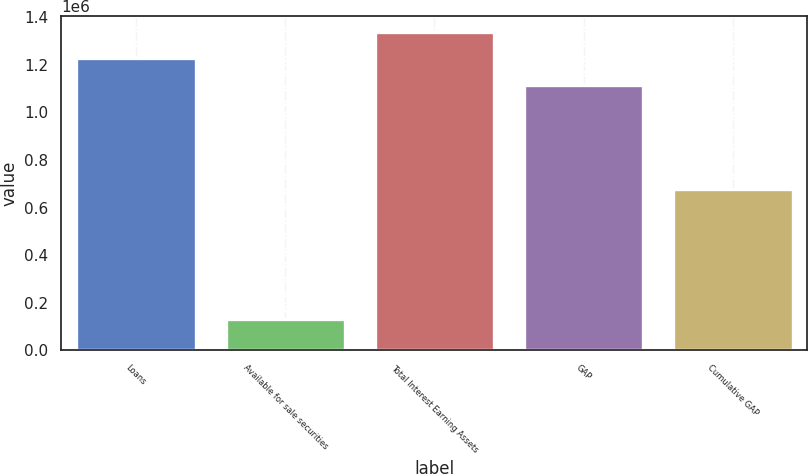Convert chart to OTSL. <chart><loc_0><loc_0><loc_500><loc_500><bar_chart><fcel>Loans<fcel>Available for sale securities<fcel>Total Interest Earning Assets<fcel>GAP<fcel>Cumulative GAP<nl><fcel>1.22692e+06<fcel>130110<fcel>1.3396e+06<fcel>1.11424e+06<fcel>679537<nl></chart> 